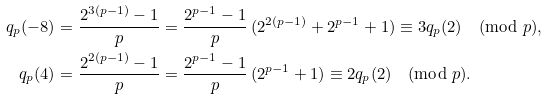Convert formula to latex. <formula><loc_0><loc_0><loc_500><loc_500>q _ { p } ( - 8 ) & = \frac { 2 ^ { 3 ( p - 1 ) } - 1 } p = \frac { 2 ^ { p - 1 } - 1 } p \, ( 2 ^ { 2 ( p - 1 ) } + 2 ^ { p - 1 } + 1 ) \equiv 3 q _ { p } ( 2 ) \pmod { p } , \\ q _ { p } ( 4 ) & = \frac { 2 ^ { 2 ( p - 1 ) } - 1 } p = \frac { 2 ^ { p - 1 } - 1 } p \, ( 2 ^ { p - 1 } + 1 ) \equiv 2 q _ { p } ( 2 ) \pmod { p } .</formula> 